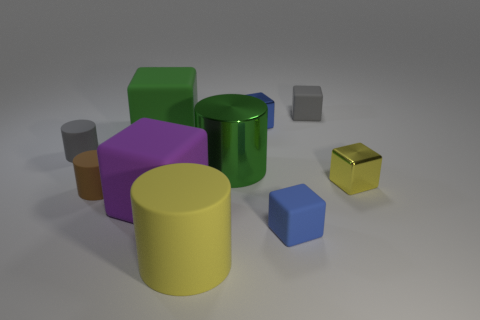Subtract all blue cylinders. How many blue cubes are left? 2 Subtract 2 cubes. How many cubes are left? 4 Subtract all gray cubes. How many cubes are left? 5 Subtract all tiny yellow cubes. How many cubes are left? 5 Subtract all cyan cylinders. Subtract all red balls. How many cylinders are left? 4 Subtract all cylinders. How many objects are left? 6 Subtract all small brown shiny things. Subtract all tiny yellow blocks. How many objects are left? 9 Add 5 small blue rubber cubes. How many small blue rubber cubes are left? 6 Add 9 big blue matte objects. How many big blue matte objects exist? 9 Subtract 0 brown blocks. How many objects are left? 10 